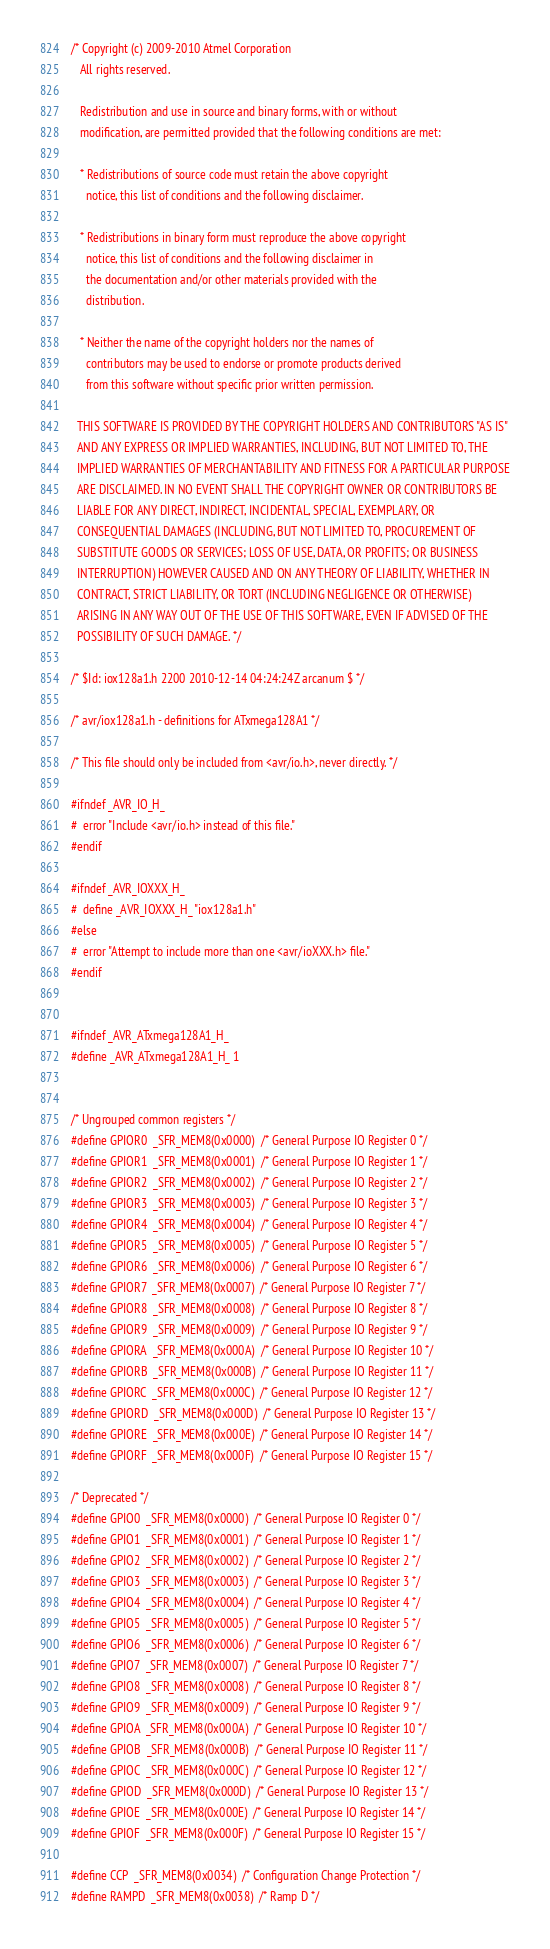Convert code to text. <code><loc_0><loc_0><loc_500><loc_500><_C_>/* Copyright (c) 2009-2010 Atmel Corporation
   All rights reserved.

   Redistribution and use in source and binary forms, with or without
   modification, are permitted provided that the following conditions are met:

   * Redistributions of source code must retain the above copyright
     notice, this list of conditions and the following disclaimer.

   * Redistributions in binary form must reproduce the above copyright
     notice, this list of conditions and the following disclaimer in
     the documentation and/or other materials provided with the
     distribution.

   * Neither the name of the copyright holders nor the names of
     contributors may be used to endorse or promote products derived
     from this software without specific prior written permission.

  THIS SOFTWARE IS PROVIDED BY THE COPYRIGHT HOLDERS AND CONTRIBUTORS "AS IS"
  AND ANY EXPRESS OR IMPLIED WARRANTIES, INCLUDING, BUT NOT LIMITED TO, THE
  IMPLIED WARRANTIES OF MERCHANTABILITY AND FITNESS FOR A PARTICULAR PURPOSE
  ARE DISCLAIMED. IN NO EVENT SHALL THE COPYRIGHT OWNER OR CONTRIBUTORS BE
  LIABLE FOR ANY DIRECT, INDIRECT, INCIDENTAL, SPECIAL, EXEMPLARY, OR
  CONSEQUENTIAL DAMAGES (INCLUDING, BUT NOT LIMITED TO, PROCUREMENT OF
  SUBSTITUTE GOODS OR SERVICES; LOSS OF USE, DATA, OR PROFITS; OR BUSINESS
  INTERRUPTION) HOWEVER CAUSED AND ON ANY THEORY OF LIABILITY, WHETHER IN
  CONTRACT, STRICT LIABILITY, OR TORT (INCLUDING NEGLIGENCE OR OTHERWISE)
  ARISING IN ANY WAY OUT OF THE USE OF THIS SOFTWARE, EVEN IF ADVISED OF THE
  POSSIBILITY OF SUCH DAMAGE. */

/* $Id: iox128a1.h 2200 2010-12-14 04:24:24Z arcanum $ */

/* avr/iox128a1.h - definitions for ATxmega128A1 */

/* This file should only be included from <avr/io.h>, never directly. */

#ifndef _AVR_IO_H_
#  error "Include <avr/io.h> instead of this file."
#endif

#ifndef _AVR_IOXXX_H_
#  define _AVR_IOXXX_H_ "iox128a1.h"
#else
#  error "Attempt to include more than one <avr/ioXXX.h> file."
#endif 


#ifndef _AVR_ATxmega128A1_H_
#define _AVR_ATxmega128A1_H_ 1


/* Ungrouped common registers */
#define GPIOR0  _SFR_MEM8(0x0000)  /* General Purpose IO Register 0 */
#define GPIOR1  _SFR_MEM8(0x0001)  /* General Purpose IO Register 1 */
#define GPIOR2  _SFR_MEM8(0x0002)  /* General Purpose IO Register 2 */
#define GPIOR3  _SFR_MEM8(0x0003)  /* General Purpose IO Register 3 */
#define GPIOR4  _SFR_MEM8(0x0004)  /* General Purpose IO Register 4 */
#define GPIOR5  _SFR_MEM8(0x0005)  /* General Purpose IO Register 5 */
#define GPIOR6  _SFR_MEM8(0x0006)  /* General Purpose IO Register 6 */
#define GPIOR7  _SFR_MEM8(0x0007)  /* General Purpose IO Register 7 */
#define GPIOR8  _SFR_MEM8(0x0008)  /* General Purpose IO Register 8 */
#define GPIOR9  _SFR_MEM8(0x0009)  /* General Purpose IO Register 9 */
#define GPIORA  _SFR_MEM8(0x000A)  /* General Purpose IO Register 10 */
#define GPIORB  _SFR_MEM8(0x000B)  /* General Purpose IO Register 11 */
#define GPIORC  _SFR_MEM8(0x000C)  /* General Purpose IO Register 12 */
#define GPIORD  _SFR_MEM8(0x000D)  /* General Purpose IO Register 13 */
#define GPIORE  _SFR_MEM8(0x000E)  /* General Purpose IO Register 14 */
#define GPIORF  _SFR_MEM8(0x000F)  /* General Purpose IO Register 15 */

/* Deprecated */
#define GPIO0  _SFR_MEM8(0x0000)  /* General Purpose IO Register 0 */
#define GPIO1  _SFR_MEM8(0x0001)  /* General Purpose IO Register 1 */
#define GPIO2  _SFR_MEM8(0x0002)  /* General Purpose IO Register 2 */
#define GPIO3  _SFR_MEM8(0x0003)  /* General Purpose IO Register 3 */
#define GPIO4  _SFR_MEM8(0x0004)  /* General Purpose IO Register 4 */
#define GPIO5  _SFR_MEM8(0x0005)  /* General Purpose IO Register 5 */
#define GPIO6  _SFR_MEM8(0x0006)  /* General Purpose IO Register 6 */
#define GPIO7  _SFR_MEM8(0x0007)  /* General Purpose IO Register 7 */
#define GPIO8  _SFR_MEM8(0x0008)  /* General Purpose IO Register 8 */
#define GPIO9  _SFR_MEM8(0x0009)  /* General Purpose IO Register 9 */
#define GPIOA  _SFR_MEM8(0x000A)  /* General Purpose IO Register 10 */
#define GPIOB  _SFR_MEM8(0x000B)  /* General Purpose IO Register 11 */
#define GPIOC  _SFR_MEM8(0x000C)  /* General Purpose IO Register 12 */
#define GPIOD  _SFR_MEM8(0x000D)  /* General Purpose IO Register 13 */
#define GPIOE  _SFR_MEM8(0x000E)  /* General Purpose IO Register 14 */
#define GPIOF  _SFR_MEM8(0x000F)  /* General Purpose IO Register 15 */

#define CCP  _SFR_MEM8(0x0034)  /* Configuration Change Protection */
#define RAMPD  _SFR_MEM8(0x0038)  /* Ramp D */</code> 